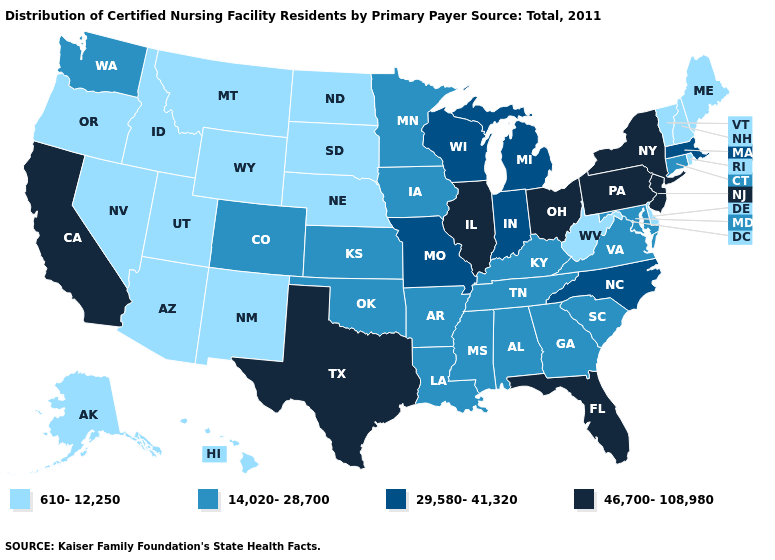What is the highest value in the USA?
Answer briefly. 46,700-108,980. What is the highest value in states that border New Mexico?
Keep it brief. 46,700-108,980. What is the lowest value in the USA?
Answer briefly. 610-12,250. What is the value of Mississippi?
Write a very short answer. 14,020-28,700. Name the states that have a value in the range 46,700-108,980?
Write a very short answer. California, Florida, Illinois, New Jersey, New York, Ohio, Pennsylvania, Texas. Does the first symbol in the legend represent the smallest category?
Concise answer only. Yes. What is the lowest value in the West?
Quick response, please. 610-12,250. What is the value of Kansas?
Quick response, please. 14,020-28,700. Does Delaware have the lowest value in the USA?
Be succinct. Yes. Name the states that have a value in the range 14,020-28,700?
Write a very short answer. Alabama, Arkansas, Colorado, Connecticut, Georgia, Iowa, Kansas, Kentucky, Louisiana, Maryland, Minnesota, Mississippi, Oklahoma, South Carolina, Tennessee, Virginia, Washington. What is the value of Minnesota?
Answer briefly. 14,020-28,700. Does New York have the highest value in the Northeast?
Be succinct. Yes. Name the states that have a value in the range 29,580-41,320?
Write a very short answer. Indiana, Massachusetts, Michigan, Missouri, North Carolina, Wisconsin. Among the states that border Maryland , which have the highest value?
Write a very short answer. Pennsylvania. 